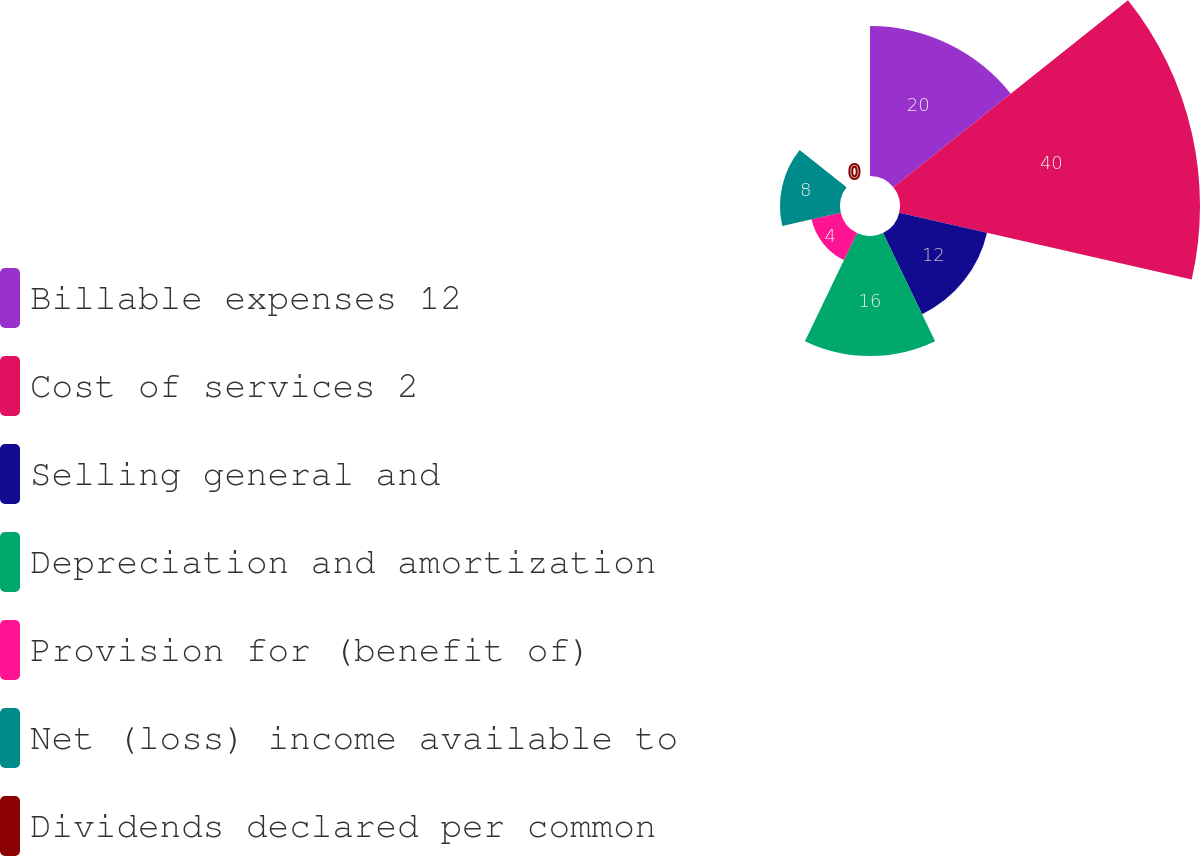Convert chart. <chart><loc_0><loc_0><loc_500><loc_500><pie_chart><fcel>Billable expenses 12<fcel>Cost of services 2<fcel>Selling general and<fcel>Depreciation and amortization<fcel>Provision for (benefit of)<fcel>Net (loss) income available to<fcel>Dividends declared per common<nl><fcel>20.0%<fcel>39.99%<fcel>12.0%<fcel>16.0%<fcel>4.0%<fcel>8.0%<fcel>0.0%<nl></chart> 